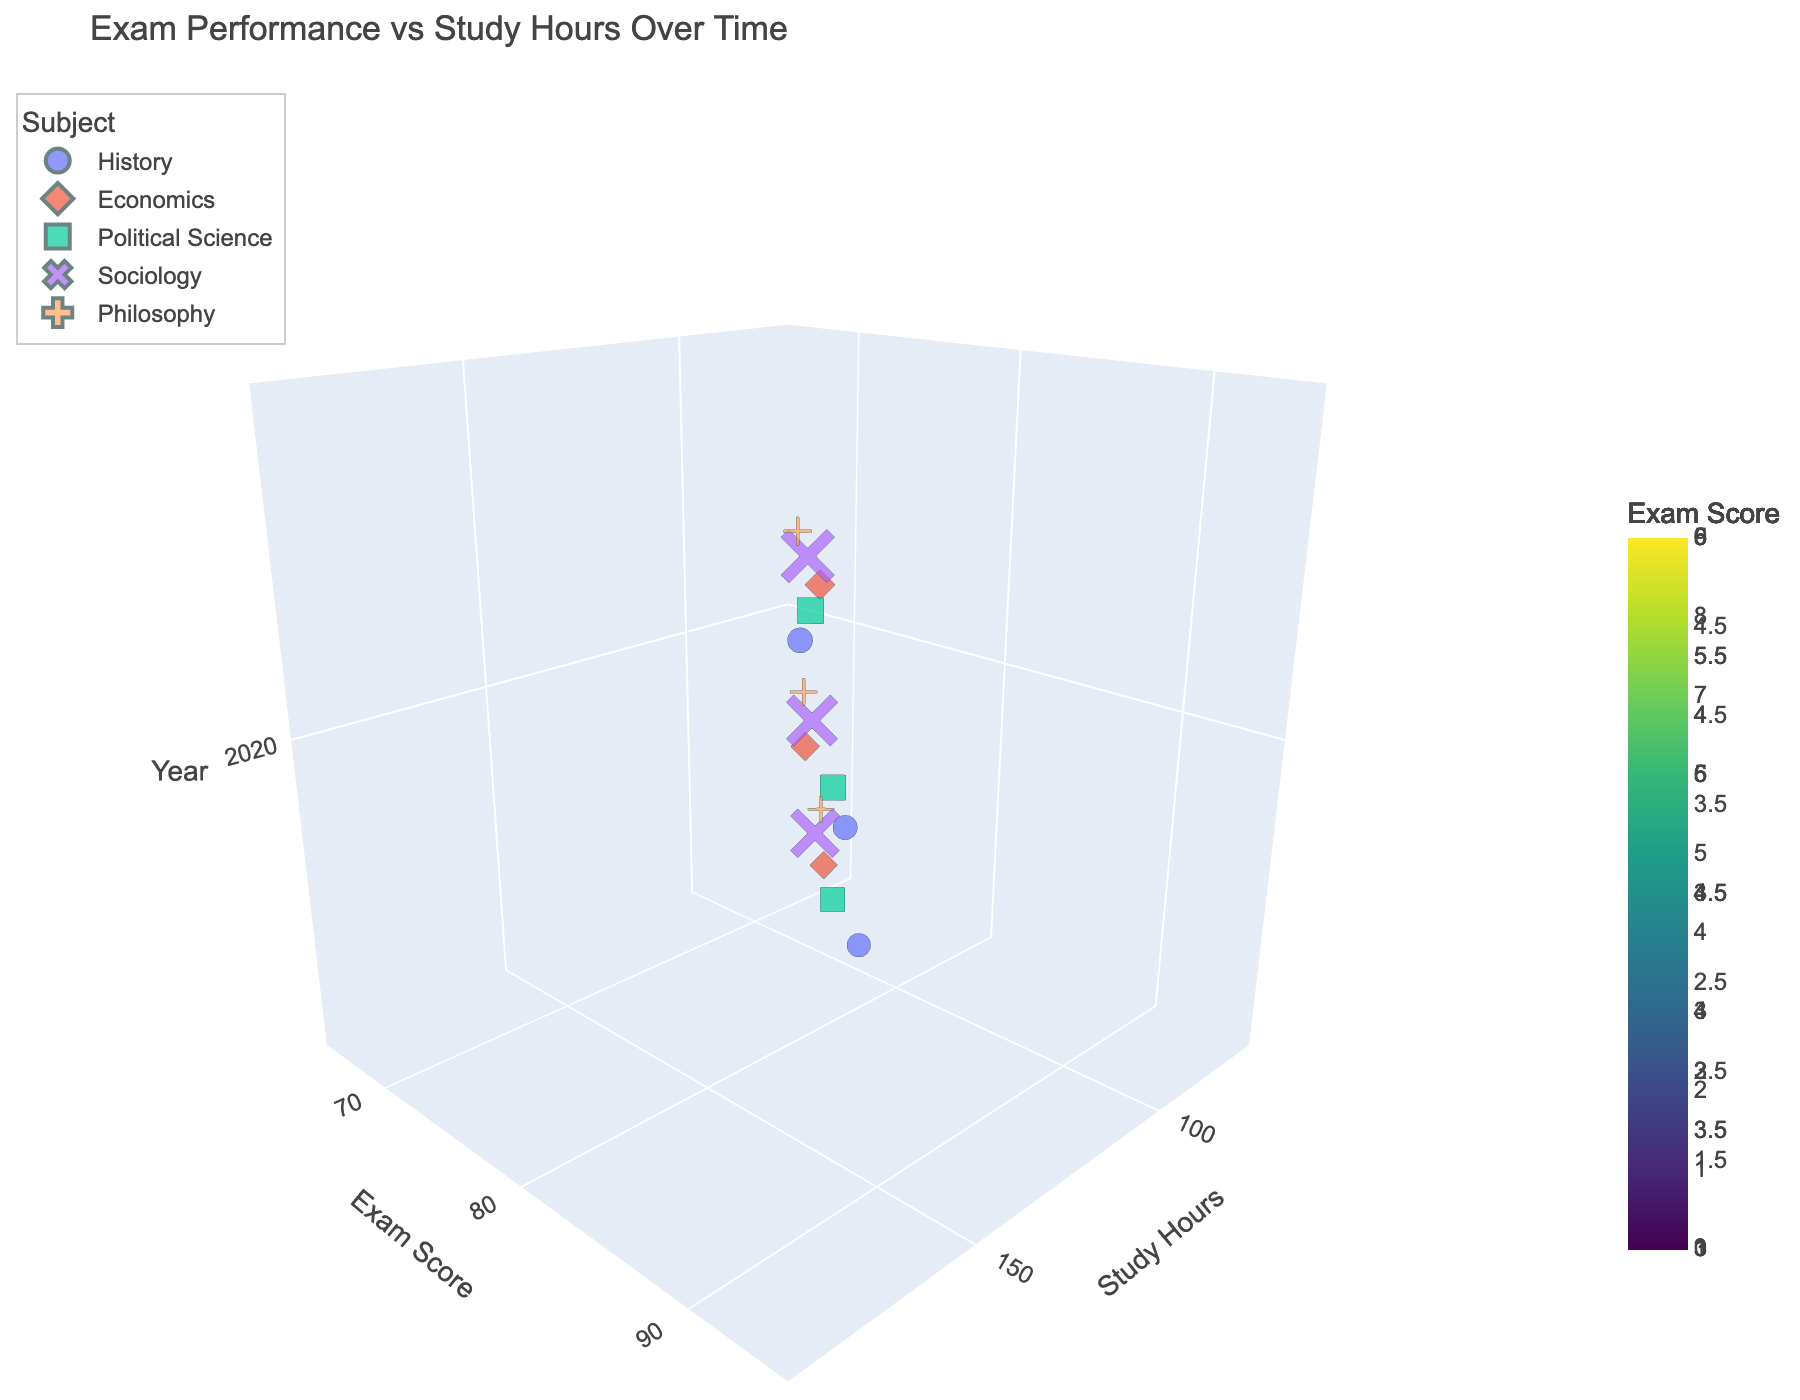What is the title of the figure? The title of the figure is positioned at the top and usually summarizes what the chart represents. In this case, the title "Exam Performance vs Study Hours Over Time" is explicitly shown at the top.
Answer: Exam Performance vs Study Hours Over Time What are the labels of the axes? Axis labels are given to add clarity to the chart. The x-axis is labeled "Study Hours," the y-axis is labeled "Exam Score," and the z-axis is labeled "Year."
Answer: Study Hours, Exam Score, Year How many subjects are represented in the figure? Each data point has a specific color and symbol associated with a subject. The legend shows the different subjects included in the figure. By checking the legend, five unique subjects can be identified.
Answer: 5 What is the total number of study hours for Philosophy across all years? To find the total number of study hours for Philosophy, sum the study hours for each year: 80 (2019), 110 (2020), and 140 (2021). So, 80 + 110 + 140 = 330.
Answer: 330 What is the average exam score for Sociology across all years? First, sum the exam scores for Sociology for each year: 72 (2019), 79 (2020), and 86 (2021). The sum is 72 + 79 + 86 = 237. Then, divide by the number of years (3): 237/3 = 79.
Answer: 79 Which subject has the highest exam score in 2021? By looking at the data points corresponding to the year 2021 (z-axis value 2021), we can compare the exam scores (y-axis value). Political Science has the highest exam score of 91 in 2021.
Answer: Political Science In which year did History achieve the highest exam score? Observe the data points for History across all years. The exam scores are 82 (2019), 88 (2020), and 93 (2021). The highest score is 93, and it occurred in 2021.
Answer: 2021 Which subject has the lowest study hours in 2019? By checking the data points for the year 2019, look for the smallest value along the study hours (x-axis). The subject with the lowest study hours of 80 in 2019 is Philosophy.
Answer: Philosophy How does the exam score trend for Economics change from 2019 to 2021? The trend can be observed by following the data points for Economics over the years. The exam score increases from 75 in 2019 to 81 in 2020, and finally to 89 in 2021, showing an overall upward trend.
Answer: Upward trend How is the camera angle set in the figure? The camera angle is described in the layout settings. The eye coordinates provided are (x=1.5, y=1.5, z=0.8), indicating that the view is rotated and elevated to provide a clear three-dimensional perspective.
Answer: x=1.5, y=1.5, z=0.8 